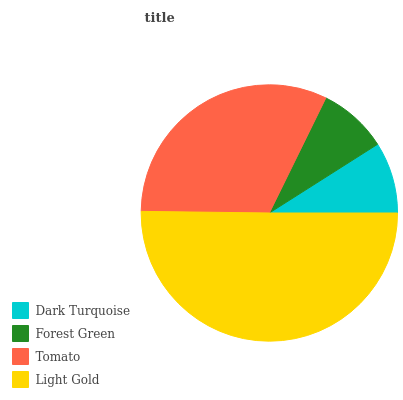Is Forest Green the minimum?
Answer yes or no. Yes. Is Light Gold the maximum?
Answer yes or no. Yes. Is Tomato the minimum?
Answer yes or no. No. Is Tomato the maximum?
Answer yes or no. No. Is Tomato greater than Forest Green?
Answer yes or no. Yes. Is Forest Green less than Tomato?
Answer yes or no. Yes. Is Forest Green greater than Tomato?
Answer yes or no. No. Is Tomato less than Forest Green?
Answer yes or no. No. Is Tomato the high median?
Answer yes or no. Yes. Is Dark Turquoise the low median?
Answer yes or no. Yes. Is Forest Green the high median?
Answer yes or no. No. Is Forest Green the low median?
Answer yes or no. No. 